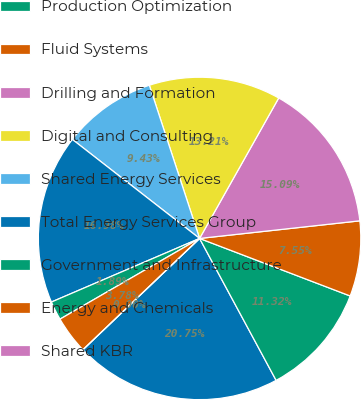<chart> <loc_0><loc_0><loc_500><loc_500><pie_chart><fcel>Millions of dollars<fcel>Production Optimization<fcel>Fluid Systems<fcel>Drilling and Formation<fcel>Digital and Consulting<fcel>Shared Energy Services<fcel>Total Energy Services Group<fcel>Government and Infrastructure<fcel>Energy and Chemicals<fcel>Shared KBR<nl><fcel>20.75%<fcel>11.32%<fcel>7.55%<fcel>15.09%<fcel>13.21%<fcel>9.43%<fcel>16.98%<fcel>1.89%<fcel>3.78%<fcel>0.0%<nl></chart> 